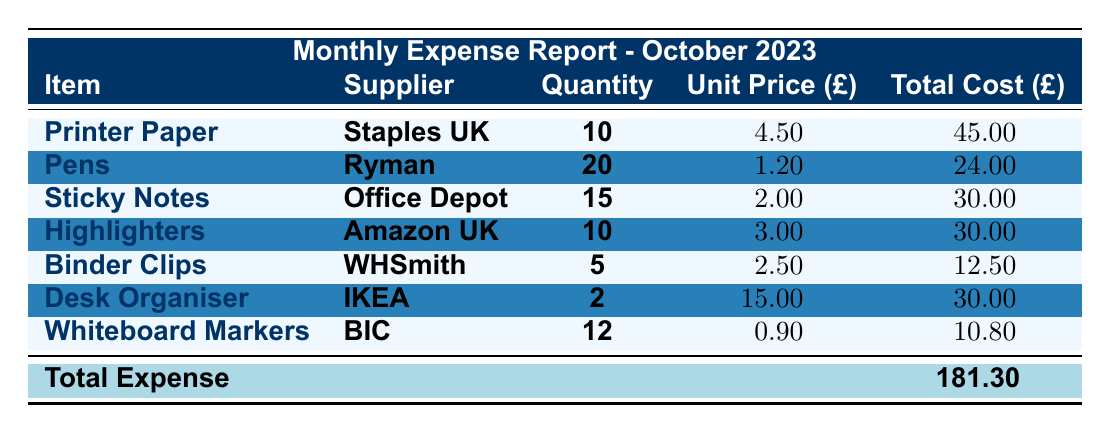What is the total expense reported for October 2023? The total expense for October 2023 is listed as £181.30 in the table.
Answer: £181.30 Which supplier provided the Desk Organiser? The supplier for the Desk Organiser is indicated as IKEA in the table.
Answer: IKEA How many units of Whiteboard Markers were purchased? The table shows that 12 units of Whiteboard Markers were purchased.
Answer: 12 What is the total cost of Sticky Notes? The total cost for Sticky Notes is given as £30.00 in the table.
Answer: £30.00 What is the average unit price of all items listed? To find the average unit price, sum the unit prices (4.50 + 1.20 + 2.00 + 3.00 + 2.50 + 15.00 + 0.90) = 29.10. There are 7 items, so the average is 29.10 / 7 ≈ 4.16.
Answer: £4.16 How much did the highest expense item cost? The highest expense in the table is Printer Paper, which cost £45.00.
Answer: £45.00 Is the total expense greater than £200? The total expense of £181.30 is less than £200, so the answer is no.
Answer: No What is the total quantity of all items ordered? To find the total quantity, we sum the quantities (10 + 20 + 15 + 10 + 5 + 2 + 12) = 74.
Answer: 74 Which item had the lowest total cost, and what was that cost? The item with the lowest total cost is Whiteboard Markers at £10.80. To confirm, we see the costs listed for each item.
Answer: Whiteboard Markers, £10.80 If we remove the expense for Highlighters, what will be the new total expense? Removing the cost of Highlighters (£30.00) from the total expense (£181.30) gives us £181.30 - £30.00 = £151.30.
Answer: £151.30 